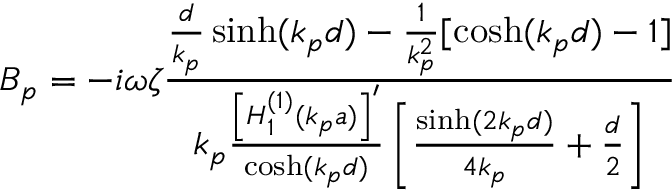<formula> <loc_0><loc_0><loc_500><loc_500>B _ { p } = - i \omega \zeta \frac { \frac { d } { k _ { p } } \sinh ( k _ { p } d ) - \frac { 1 } { k _ { p } ^ { 2 } } [ \cosh ( k _ { p } d ) - 1 ] } { k _ { p } \frac { \left [ H _ { 1 } ^ { ( 1 ) } ( k _ { p } a ) \right ] ^ { \prime } } { \cosh ( k _ { p } d ) } \left [ \frac { \sinh ( 2 k _ { p } d ) } { 4 k _ { p } } + \frac { d } { 2 } \right ] }</formula> 